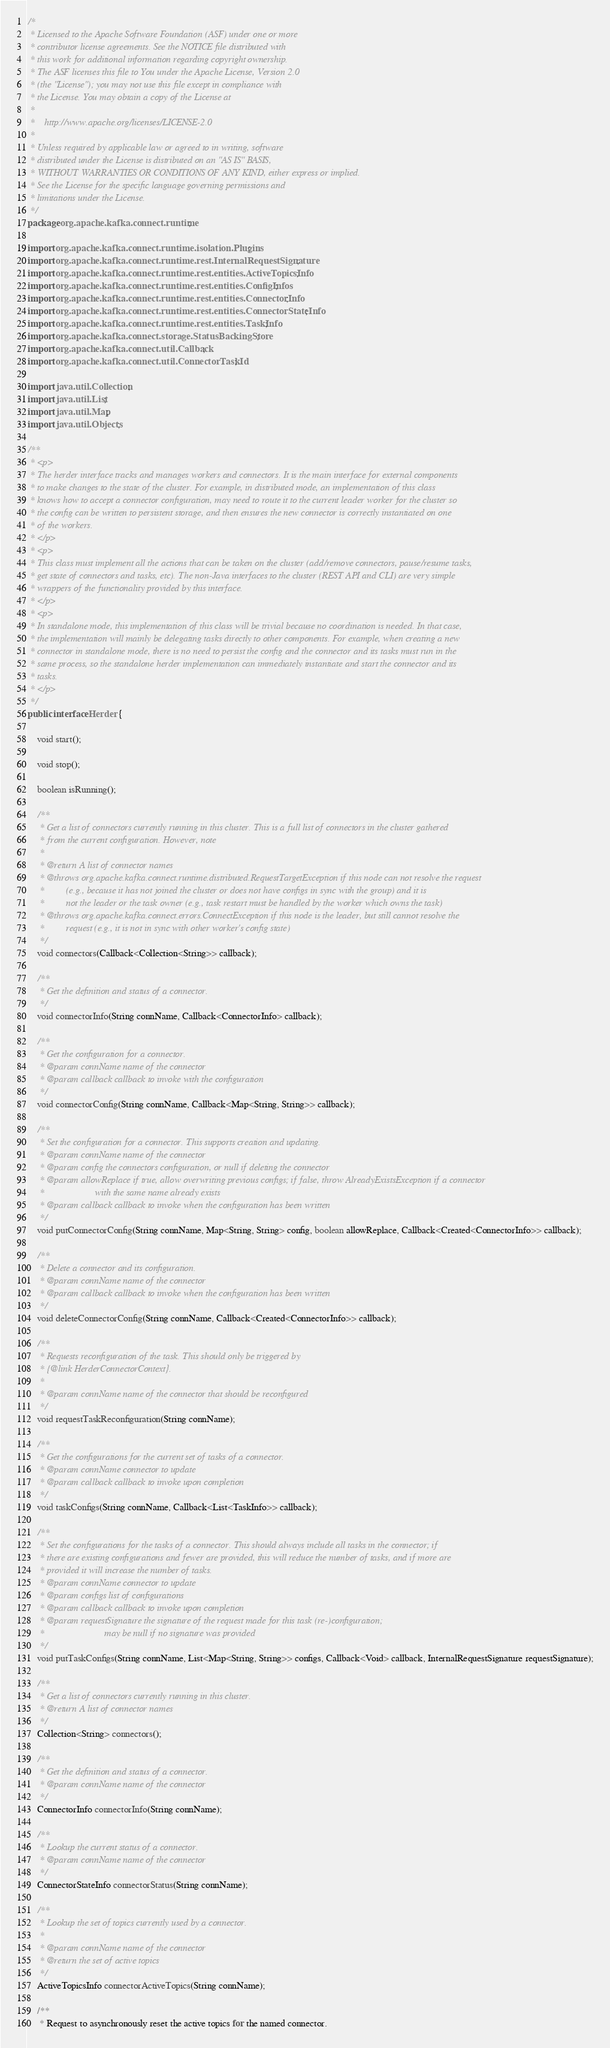Convert code to text. <code><loc_0><loc_0><loc_500><loc_500><_Java_>/*
 * Licensed to the Apache Software Foundation (ASF) under one or more
 * contributor license agreements. See the NOTICE file distributed with
 * this work for additional information regarding copyright ownership.
 * The ASF licenses this file to You under the Apache License, Version 2.0
 * (the "License"); you may not use this file except in compliance with
 * the License. You may obtain a copy of the License at
 *
 *    http://www.apache.org/licenses/LICENSE-2.0
 *
 * Unless required by applicable law or agreed to in writing, software
 * distributed under the License is distributed on an "AS IS" BASIS,
 * WITHOUT WARRANTIES OR CONDITIONS OF ANY KIND, either express or implied.
 * See the License for the specific language governing permissions and
 * limitations under the License.
 */
package org.apache.kafka.connect.runtime;

import org.apache.kafka.connect.runtime.isolation.Plugins;
import org.apache.kafka.connect.runtime.rest.InternalRequestSignature;
import org.apache.kafka.connect.runtime.rest.entities.ActiveTopicsInfo;
import org.apache.kafka.connect.runtime.rest.entities.ConfigInfos;
import org.apache.kafka.connect.runtime.rest.entities.ConnectorInfo;
import org.apache.kafka.connect.runtime.rest.entities.ConnectorStateInfo;
import org.apache.kafka.connect.runtime.rest.entities.TaskInfo;
import org.apache.kafka.connect.storage.StatusBackingStore;
import org.apache.kafka.connect.util.Callback;
import org.apache.kafka.connect.util.ConnectorTaskId;

import java.util.Collection;
import java.util.List;
import java.util.Map;
import java.util.Objects;

/**
 * <p>
 * The herder interface tracks and manages workers and connectors. It is the main interface for external components
 * to make changes to the state of the cluster. For example, in distributed mode, an implementation of this class
 * knows how to accept a connector configuration, may need to route it to the current leader worker for the cluster so
 * the config can be written to persistent storage, and then ensures the new connector is correctly instantiated on one
 * of the workers.
 * </p>
 * <p>
 * This class must implement all the actions that can be taken on the cluster (add/remove connectors, pause/resume tasks,
 * get state of connectors and tasks, etc). The non-Java interfaces to the cluster (REST API and CLI) are very simple
 * wrappers of the functionality provided by this interface.
 * </p>
 * <p>
 * In standalone mode, this implementation of this class will be trivial because no coordination is needed. In that case,
 * the implementation will mainly be delegating tasks directly to other components. For example, when creating a new
 * connector in standalone mode, there is no need to persist the config and the connector and its tasks must run in the
 * same process, so the standalone herder implementation can immediately instantiate and start the connector and its
 * tasks.
 * </p>
 */
public interface Herder {

    void start();

    void stop();

    boolean isRunning();

    /**
     * Get a list of connectors currently running in this cluster. This is a full list of connectors in the cluster gathered
     * from the current configuration. However, note
     *
     * @return A list of connector names
     * @throws org.apache.kafka.connect.runtime.distributed.RequestTargetException if this node can not resolve the request
     *         (e.g., because it has not joined the cluster or does not have configs in sync with the group) and it is
     *         not the leader or the task owner (e.g., task restart must be handled by the worker which owns the task)
     * @throws org.apache.kafka.connect.errors.ConnectException if this node is the leader, but still cannot resolve the
     *         request (e.g., it is not in sync with other worker's config state)
     */
    void connectors(Callback<Collection<String>> callback);

    /**
     * Get the definition and status of a connector.
     */
    void connectorInfo(String connName, Callback<ConnectorInfo> callback);

    /**
     * Get the configuration for a connector.
     * @param connName name of the connector
     * @param callback callback to invoke with the configuration
     */
    void connectorConfig(String connName, Callback<Map<String, String>> callback);

    /**
     * Set the configuration for a connector. This supports creation and updating.
     * @param connName name of the connector
     * @param config the connectors configuration, or null if deleting the connector
     * @param allowReplace if true, allow overwriting previous configs; if false, throw AlreadyExistsException if a connector
     *                     with the same name already exists
     * @param callback callback to invoke when the configuration has been written
     */
    void putConnectorConfig(String connName, Map<String, String> config, boolean allowReplace, Callback<Created<ConnectorInfo>> callback);

    /**
     * Delete a connector and its configuration.
     * @param connName name of the connector
     * @param callback callback to invoke when the configuration has been written
     */
    void deleteConnectorConfig(String connName, Callback<Created<ConnectorInfo>> callback);

    /**
     * Requests reconfiguration of the task. This should only be triggered by
     * {@link HerderConnectorContext}.
     *
     * @param connName name of the connector that should be reconfigured
     */
    void requestTaskReconfiguration(String connName);

    /**
     * Get the configurations for the current set of tasks of a connector.
     * @param connName connector to update
     * @param callback callback to invoke upon completion
     */
    void taskConfigs(String connName, Callback<List<TaskInfo>> callback);

    /**
     * Set the configurations for the tasks of a connector. This should always include all tasks in the connector; if
     * there are existing configurations and fewer are provided, this will reduce the number of tasks, and if more are
     * provided it will increase the number of tasks.
     * @param connName connector to update
     * @param configs list of configurations
     * @param callback callback to invoke upon completion
     * @param requestSignature the signature of the request made for this task (re-)configuration;
     *                         may be null if no signature was provided
     */
    void putTaskConfigs(String connName, List<Map<String, String>> configs, Callback<Void> callback, InternalRequestSignature requestSignature);

    /**
     * Get a list of connectors currently running in this cluster.
     * @return A list of connector names
     */
    Collection<String> connectors();

    /**
     * Get the definition and status of a connector.
     * @param connName name of the connector
     */
    ConnectorInfo connectorInfo(String connName);

    /**
     * Lookup the current status of a connector.
     * @param connName name of the connector
     */
    ConnectorStateInfo connectorStatus(String connName);

    /**
     * Lookup the set of topics currently used by a connector.
     *
     * @param connName name of the connector
     * @return the set of active topics
     */
    ActiveTopicsInfo connectorActiveTopics(String connName);

    /**
     * Request to asynchronously reset the active topics for the named connector.</code> 